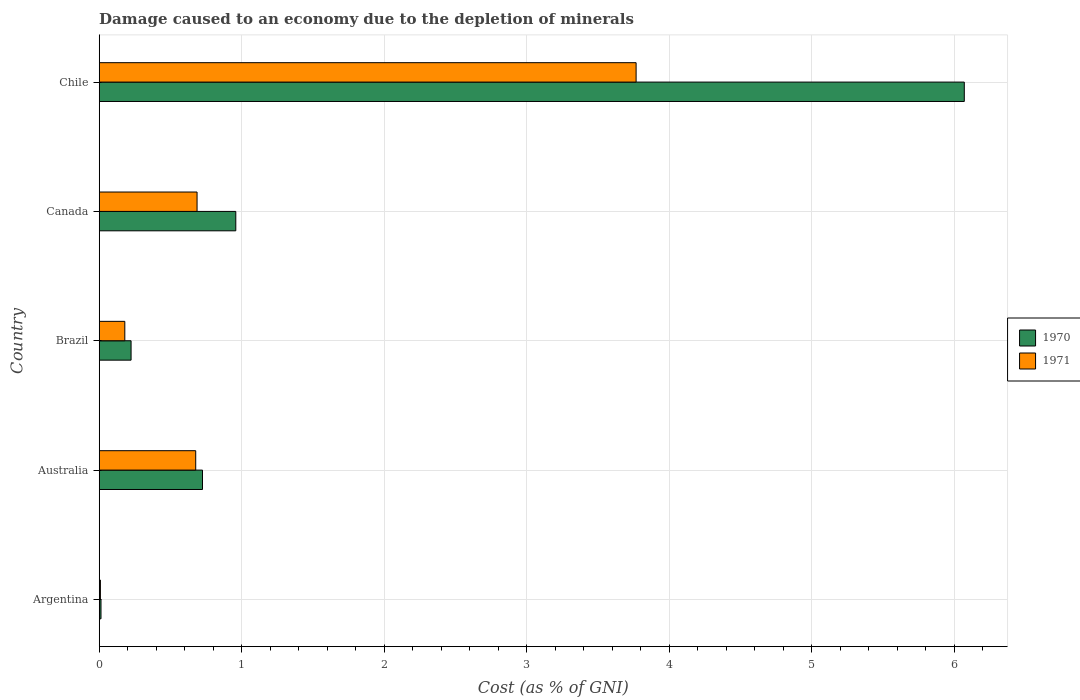How many bars are there on the 4th tick from the top?
Keep it short and to the point. 2. What is the label of the 2nd group of bars from the top?
Provide a succinct answer. Canada. What is the cost of damage caused due to the depletion of minerals in 1971 in Canada?
Make the answer very short. 0.69. Across all countries, what is the maximum cost of damage caused due to the depletion of minerals in 1971?
Make the answer very short. 3.77. Across all countries, what is the minimum cost of damage caused due to the depletion of minerals in 1970?
Give a very brief answer. 0.01. In which country was the cost of damage caused due to the depletion of minerals in 1971 minimum?
Offer a terse response. Argentina. What is the total cost of damage caused due to the depletion of minerals in 1971 in the graph?
Ensure brevity in your answer.  5.32. What is the difference between the cost of damage caused due to the depletion of minerals in 1971 in Argentina and that in Chile?
Ensure brevity in your answer.  -3.76. What is the difference between the cost of damage caused due to the depletion of minerals in 1970 in Brazil and the cost of damage caused due to the depletion of minerals in 1971 in Argentina?
Your response must be concise. 0.22. What is the average cost of damage caused due to the depletion of minerals in 1970 per country?
Your answer should be very brief. 1.6. What is the difference between the cost of damage caused due to the depletion of minerals in 1970 and cost of damage caused due to the depletion of minerals in 1971 in Brazil?
Keep it short and to the point. 0.04. What is the ratio of the cost of damage caused due to the depletion of minerals in 1971 in Canada to that in Chile?
Give a very brief answer. 0.18. Is the cost of damage caused due to the depletion of minerals in 1971 in Argentina less than that in Chile?
Keep it short and to the point. Yes. What is the difference between the highest and the second highest cost of damage caused due to the depletion of minerals in 1971?
Give a very brief answer. 3.08. What is the difference between the highest and the lowest cost of damage caused due to the depletion of minerals in 1970?
Ensure brevity in your answer.  6.06. In how many countries, is the cost of damage caused due to the depletion of minerals in 1970 greater than the average cost of damage caused due to the depletion of minerals in 1970 taken over all countries?
Make the answer very short. 1. What does the 2nd bar from the top in Brazil represents?
Provide a short and direct response. 1970. What does the 1st bar from the bottom in Chile represents?
Provide a succinct answer. 1970. How many bars are there?
Offer a very short reply. 10. Are the values on the major ticks of X-axis written in scientific E-notation?
Ensure brevity in your answer.  No. Does the graph contain any zero values?
Offer a very short reply. No. Where does the legend appear in the graph?
Make the answer very short. Center right. How many legend labels are there?
Your response must be concise. 2. How are the legend labels stacked?
Your answer should be very brief. Vertical. What is the title of the graph?
Provide a succinct answer. Damage caused to an economy due to the depletion of minerals. What is the label or title of the X-axis?
Provide a short and direct response. Cost (as % of GNI). What is the Cost (as % of GNI) of 1970 in Argentina?
Keep it short and to the point. 0.01. What is the Cost (as % of GNI) in 1971 in Argentina?
Ensure brevity in your answer.  0.01. What is the Cost (as % of GNI) in 1970 in Australia?
Offer a very short reply. 0.72. What is the Cost (as % of GNI) of 1971 in Australia?
Your answer should be very brief. 0.68. What is the Cost (as % of GNI) of 1970 in Brazil?
Provide a succinct answer. 0.22. What is the Cost (as % of GNI) in 1971 in Brazil?
Provide a succinct answer. 0.18. What is the Cost (as % of GNI) of 1970 in Canada?
Your answer should be very brief. 0.96. What is the Cost (as % of GNI) in 1971 in Canada?
Offer a very short reply. 0.69. What is the Cost (as % of GNI) of 1970 in Chile?
Offer a very short reply. 6.07. What is the Cost (as % of GNI) in 1971 in Chile?
Give a very brief answer. 3.77. Across all countries, what is the maximum Cost (as % of GNI) of 1970?
Ensure brevity in your answer.  6.07. Across all countries, what is the maximum Cost (as % of GNI) of 1971?
Offer a terse response. 3.77. Across all countries, what is the minimum Cost (as % of GNI) of 1970?
Keep it short and to the point. 0.01. Across all countries, what is the minimum Cost (as % of GNI) in 1971?
Make the answer very short. 0.01. What is the total Cost (as % of GNI) of 1970 in the graph?
Your response must be concise. 7.99. What is the total Cost (as % of GNI) of 1971 in the graph?
Provide a succinct answer. 5.32. What is the difference between the Cost (as % of GNI) of 1970 in Argentina and that in Australia?
Give a very brief answer. -0.71. What is the difference between the Cost (as % of GNI) of 1971 in Argentina and that in Australia?
Offer a terse response. -0.67. What is the difference between the Cost (as % of GNI) in 1970 in Argentina and that in Brazil?
Ensure brevity in your answer.  -0.21. What is the difference between the Cost (as % of GNI) in 1971 in Argentina and that in Brazil?
Provide a succinct answer. -0.17. What is the difference between the Cost (as % of GNI) in 1970 in Argentina and that in Canada?
Your answer should be very brief. -0.95. What is the difference between the Cost (as % of GNI) of 1971 in Argentina and that in Canada?
Your answer should be very brief. -0.68. What is the difference between the Cost (as % of GNI) of 1970 in Argentina and that in Chile?
Ensure brevity in your answer.  -6.06. What is the difference between the Cost (as % of GNI) in 1971 in Argentina and that in Chile?
Your response must be concise. -3.76. What is the difference between the Cost (as % of GNI) of 1970 in Australia and that in Brazil?
Make the answer very short. 0.5. What is the difference between the Cost (as % of GNI) of 1971 in Australia and that in Brazil?
Offer a very short reply. 0.5. What is the difference between the Cost (as % of GNI) of 1970 in Australia and that in Canada?
Ensure brevity in your answer.  -0.23. What is the difference between the Cost (as % of GNI) of 1971 in Australia and that in Canada?
Ensure brevity in your answer.  -0.01. What is the difference between the Cost (as % of GNI) of 1970 in Australia and that in Chile?
Make the answer very short. -5.35. What is the difference between the Cost (as % of GNI) in 1971 in Australia and that in Chile?
Make the answer very short. -3.09. What is the difference between the Cost (as % of GNI) in 1970 in Brazil and that in Canada?
Your response must be concise. -0.73. What is the difference between the Cost (as % of GNI) in 1971 in Brazil and that in Canada?
Keep it short and to the point. -0.51. What is the difference between the Cost (as % of GNI) in 1970 in Brazil and that in Chile?
Make the answer very short. -5.85. What is the difference between the Cost (as % of GNI) of 1971 in Brazil and that in Chile?
Keep it short and to the point. -3.59. What is the difference between the Cost (as % of GNI) in 1970 in Canada and that in Chile?
Offer a very short reply. -5.11. What is the difference between the Cost (as % of GNI) of 1971 in Canada and that in Chile?
Ensure brevity in your answer.  -3.08. What is the difference between the Cost (as % of GNI) of 1970 in Argentina and the Cost (as % of GNI) of 1971 in Australia?
Keep it short and to the point. -0.66. What is the difference between the Cost (as % of GNI) of 1970 in Argentina and the Cost (as % of GNI) of 1971 in Brazil?
Keep it short and to the point. -0.17. What is the difference between the Cost (as % of GNI) of 1970 in Argentina and the Cost (as % of GNI) of 1971 in Canada?
Provide a succinct answer. -0.67. What is the difference between the Cost (as % of GNI) of 1970 in Argentina and the Cost (as % of GNI) of 1971 in Chile?
Your response must be concise. -3.76. What is the difference between the Cost (as % of GNI) of 1970 in Australia and the Cost (as % of GNI) of 1971 in Brazil?
Offer a very short reply. 0.55. What is the difference between the Cost (as % of GNI) in 1970 in Australia and the Cost (as % of GNI) in 1971 in Canada?
Your answer should be compact. 0.04. What is the difference between the Cost (as % of GNI) in 1970 in Australia and the Cost (as % of GNI) in 1971 in Chile?
Ensure brevity in your answer.  -3.04. What is the difference between the Cost (as % of GNI) in 1970 in Brazil and the Cost (as % of GNI) in 1971 in Canada?
Give a very brief answer. -0.46. What is the difference between the Cost (as % of GNI) in 1970 in Brazil and the Cost (as % of GNI) in 1971 in Chile?
Offer a terse response. -3.54. What is the difference between the Cost (as % of GNI) of 1970 in Canada and the Cost (as % of GNI) of 1971 in Chile?
Your answer should be compact. -2.81. What is the average Cost (as % of GNI) of 1970 per country?
Ensure brevity in your answer.  1.6. What is the average Cost (as % of GNI) of 1971 per country?
Ensure brevity in your answer.  1.06. What is the difference between the Cost (as % of GNI) of 1970 and Cost (as % of GNI) of 1971 in Argentina?
Keep it short and to the point. 0. What is the difference between the Cost (as % of GNI) in 1970 and Cost (as % of GNI) in 1971 in Australia?
Provide a succinct answer. 0.05. What is the difference between the Cost (as % of GNI) in 1970 and Cost (as % of GNI) in 1971 in Brazil?
Ensure brevity in your answer.  0.04. What is the difference between the Cost (as % of GNI) in 1970 and Cost (as % of GNI) in 1971 in Canada?
Provide a short and direct response. 0.27. What is the difference between the Cost (as % of GNI) of 1970 and Cost (as % of GNI) of 1971 in Chile?
Your answer should be compact. 2.3. What is the ratio of the Cost (as % of GNI) of 1970 in Argentina to that in Australia?
Your answer should be very brief. 0.02. What is the ratio of the Cost (as % of GNI) in 1971 in Argentina to that in Australia?
Give a very brief answer. 0.01. What is the ratio of the Cost (as % of GNI) in 1970 in Argentina to that in Brazil?
Provide a short and direct response. 0.06. What is the ratio of the Cost (as % of GNI) in 1971 in Argentina to that in Brazil?
Provide a succinct answer. 0.05. What is the ratio of the Cost (as % of GNI) in 1970 in Argentina to that in Canada?
Your answer should be compact. 0.01. What is the ratio of the Cost (as % of GNI) in 1971 in Argentina to that in Canada?
Provide a succinct answer. 0.01. What is the ratio of the Cost (as % of GNI) in 1970 in Argentina to that in Chile?
Keep it short and to the point. 0. What is the ratio of the Cost (as % of GNI) in 1971 in Argentina to that in Chile?
Offer a terse response. 0. What is the ratio of the Cost (as % of GNI) in 1970 in Australia to that in Brazil?
Your response must be concise. 3.24. What is the ratio of the Cost (as % of GNI) of 1971 in Australia to that in Brazil?
Ensure brevity in your answer.  3.77. What is the ratio of the Cost (as % of GNI) in 1970 in Australia to that in Canada?
Offer a very short reply. 0.76. What is the ratio of the Cost (as % of GNI) of 1971 in Australia to that in Canada?
Offer a terse response. 0.99. What is the ratio of the Cost (as % of GNI) of 1970 in Australia to that in Chile?
Your answer should be very brief. 0.12. What is the ratio of the Cost (as % of GNI) in 1971 in Australia to that in Chile?
Give a very brief answer. 0.18. What is the ratio of the Cost (as % of GNI) in 1970 in Brazil to that in Canada?
Your answer should be compact. 0.23. What is the ratio of the Cost (as % of GNI) in 1971 in Brazil to that in Canada?
Provide a succinct answer. 0.26. What is the ratio of the Cost (as % of GNI) in 1970 in Brazil to that in Chile?
Provide a short and direct response. 0.04. What is the ratio of the Cost (as % of GNI) of 1971 in Brazil to that in Chile?
Your response must be concise. 0.05. What is the ratio of the Cost (as % of GNI) in 1970 in Canada to that in Chile?
Offer a terse response. 0.16. What is the ratio of the Cost (as % of GNI) in 1971 in Canada to that in Chile?
Provide a succinct answer. 0.18. What is the difference between the highest and the second highest Cost (as % of GNI) of 1970?
Keep it short and to the point. 5.11. What is the difference between the highest and the second highest Cost (as % of GNI) of 1971?
Provide a succinct answer. 3.08. What is the difference between the highest and the lowest Cost (as % of GNI) of 1970?
Provide a succinct answer. 6.06. What is the difference between the highest and the lowest Cost (as % of GNI) of 1971?
Provide a short and direct response. 3.76. 